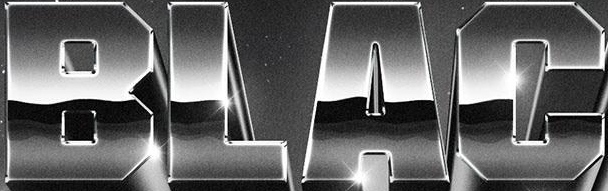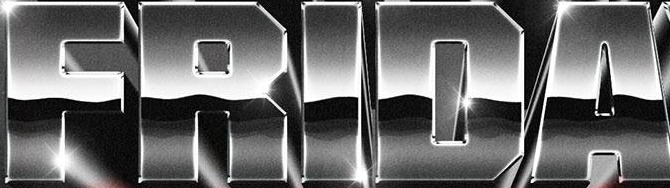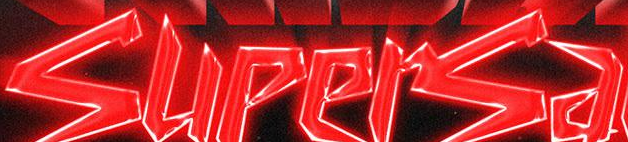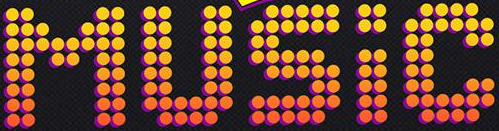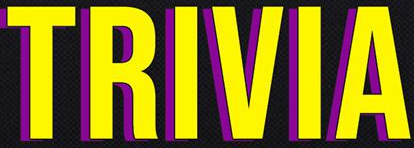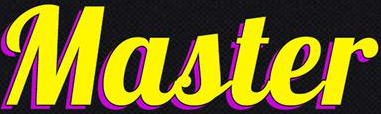Transcribe the words shown in these images in order, separated by a semicolon. BLAC; FRIDA; supersa; MUSIC; TRIVIA; Master 